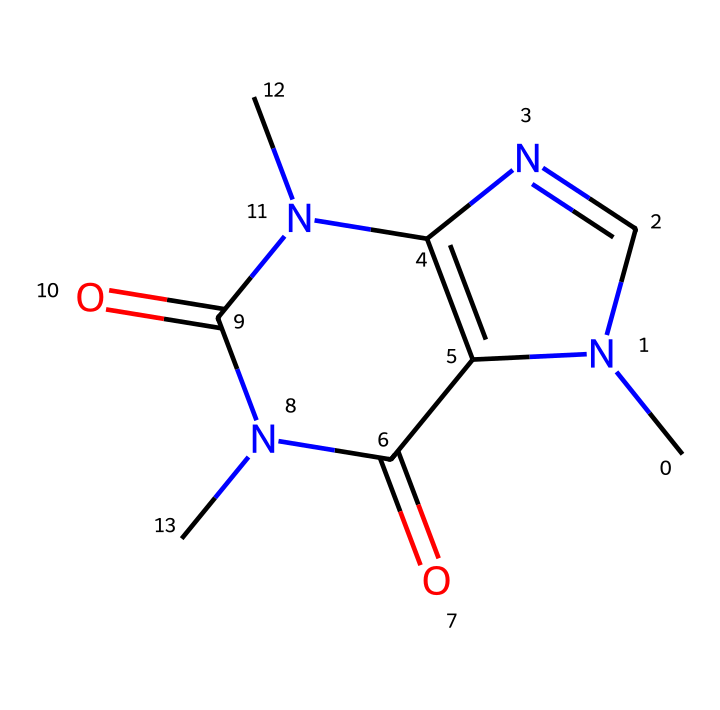What is the name of the chemical represented by the SMILES? The SMILES representation corresponds to caffeine, a well-known stimulant. We can identify this by recognizing the common structure associated with caffeine, particularly the nitrogen-containing rings typical of alkaloids.
Answer: caffeine How many nitrogen atoms are present in the chemical structure? By examining the SMILES, we can count the nitrogen atoms represented; there are three "N" symbols indicating three nitrogen atoms in the structure.
Answer: three What type of chemical compound is caffeine categorized as? Caffeine belongs to the class of compounds known as alkaloids. This classification is based on its structure, which contains nitrogen atoms and derived from plant sources, often exhibiting significant biological effects.
Answer: alkaloid Identify the total number of carbon atoms in the structure. Analyzing the SMILES representation, we count the carbon atoms indicated by the "C" symbols. There are eight "C" symbols, which means there are eight carbon atoms in this compound.
Answer: eight What functional groups are present in caffeine? The SMILES indicates that caffeine has amine groups (due to nitrogen atoms) and carbonyl groups (from the C=O connections). The arrangement of these functional groups is characteristic of many alkaloids, particularly caffeine.
Answer: amine, carbonyl How many rings are found in the chemical structure of caffeine? By breaking down the SMILES notation, we can identify two distinct ring structures formed by the connected carbon and nitrogen atoms. The numbering in the SMILES also indicates the cyclic nature of the compound.
Answer: two 